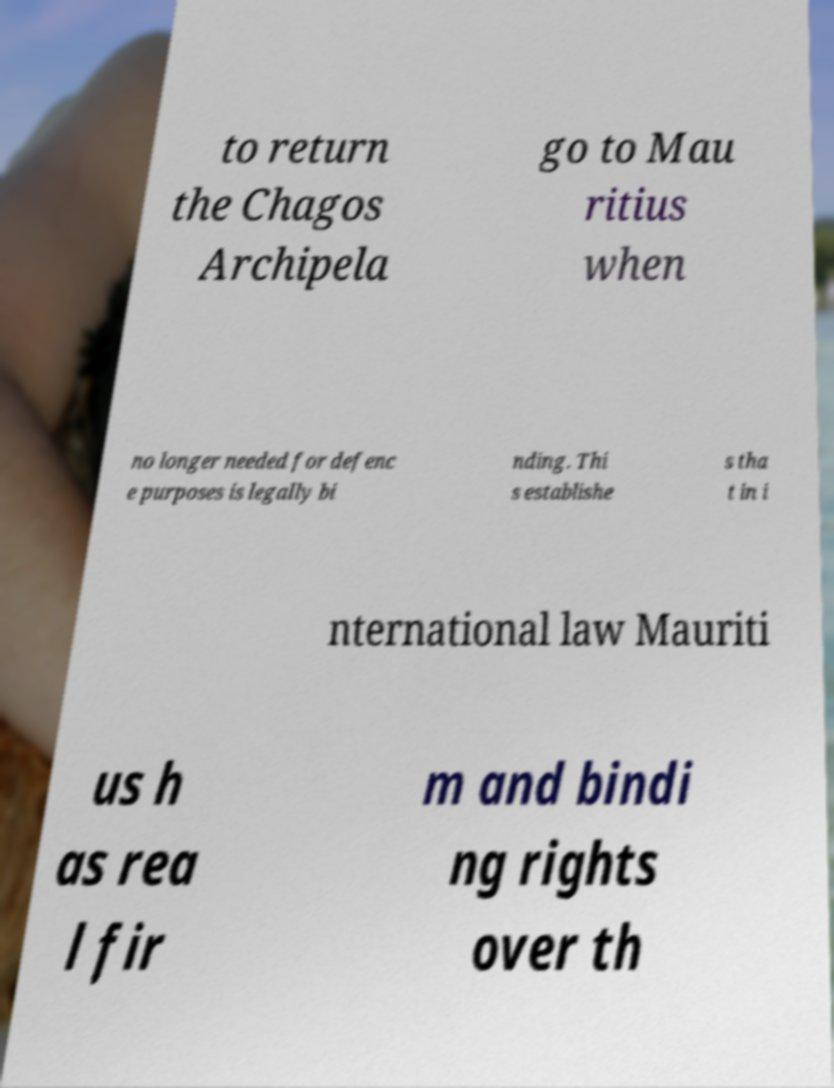Please identify and transcribe the text found in this image. to return the Chagos Archipela go to Mau ritius when no longer needed for defenc e purposes is legally bi nding. Thi s establishe s tha t in i nternational law Mauriti us h as rea l fir m and bindi ng rights over th 